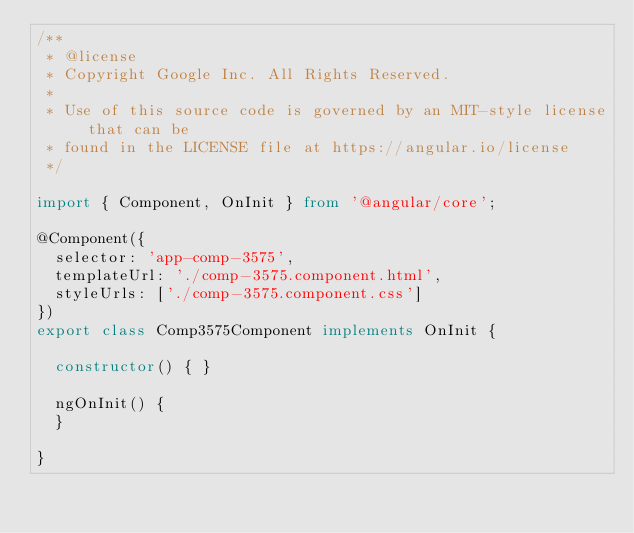<code> <loc_0><loc_0><loc_500><loc_500><_TypeScript_>/**
 * @license
 * Copyright Google Inc. All Rights Reserved.
 *
 * Use of this source code is governed by an MIT-style license that can be
 * found in the LICENSE file at https://angular.io/license
 */

import { Component, OnInit } from '@angular/core';

@Component({
  selector: 'app-comp-3575',
  templateUrl: './comp-3575.component.html',
  styleUrls: ['./comp-3575.component.css']
})
export class Comp3575Component implements OnInit {

  constructor() { }

  ngOnInit() {
  }

}
</code> 